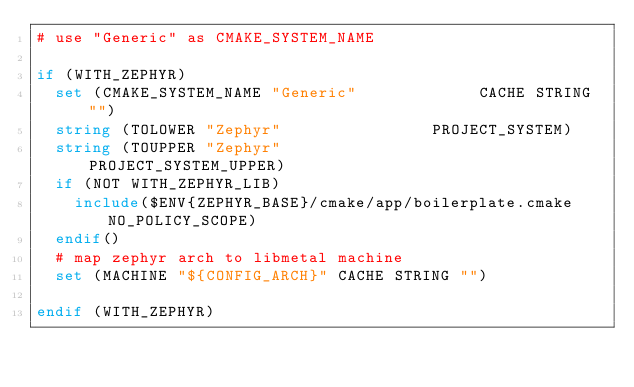Convert code to text. <code><loc_0><loc_0><loc_500><loc_500><_CMake_># use "Generic" as CMAKE_SYSTEM_NAME

if (WITH_ZEPHYR)
  set (CMAKE_SYSTEM_NAME "Generic"             CACHE STRING "")
  string (TOLOWER "Zephyr"                PROJECT_SYSTEM)
  string (TOUPPER "Zephyr"                PROJECT_SYSTEM_UPPER)
  if (NOT WITH_ZEPHYR_LIB)
    include($ENV{ZEPHYR_BASE}/cmake/app/boilerplate.cmake NO_POLICY_SCOPE)
  endif()
  # map zephyr arch to libmetal machine
  set (MACHINE "${CONFIG_ARCH}" CACHE STRING "")

endif (WITH_ZEPHYR)
</code> 